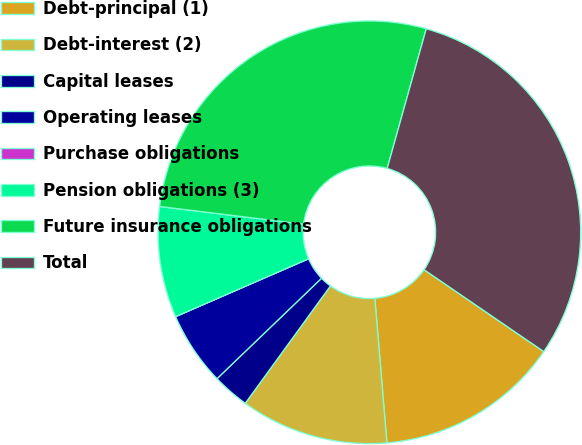<chart> <loc_0><loc_0><loc_500><loc_500><pie_chart><fcel>Debt-principal (1)<fcel>Debt-interest (2)<fcel>Capital leases<fcel>Operating leases<fcel>Purchase obligations<fcel>Pension obligations (3)<fcel>Future insurance obligations<fcel>Total<nl><fcel>14.13%<fcel>11.31%<fcel>2.83%<fcel>5.65%<fcel>0.0%<fcel>8.48%<fcel>27.39%<fcel>30.21%<nl></chart> 